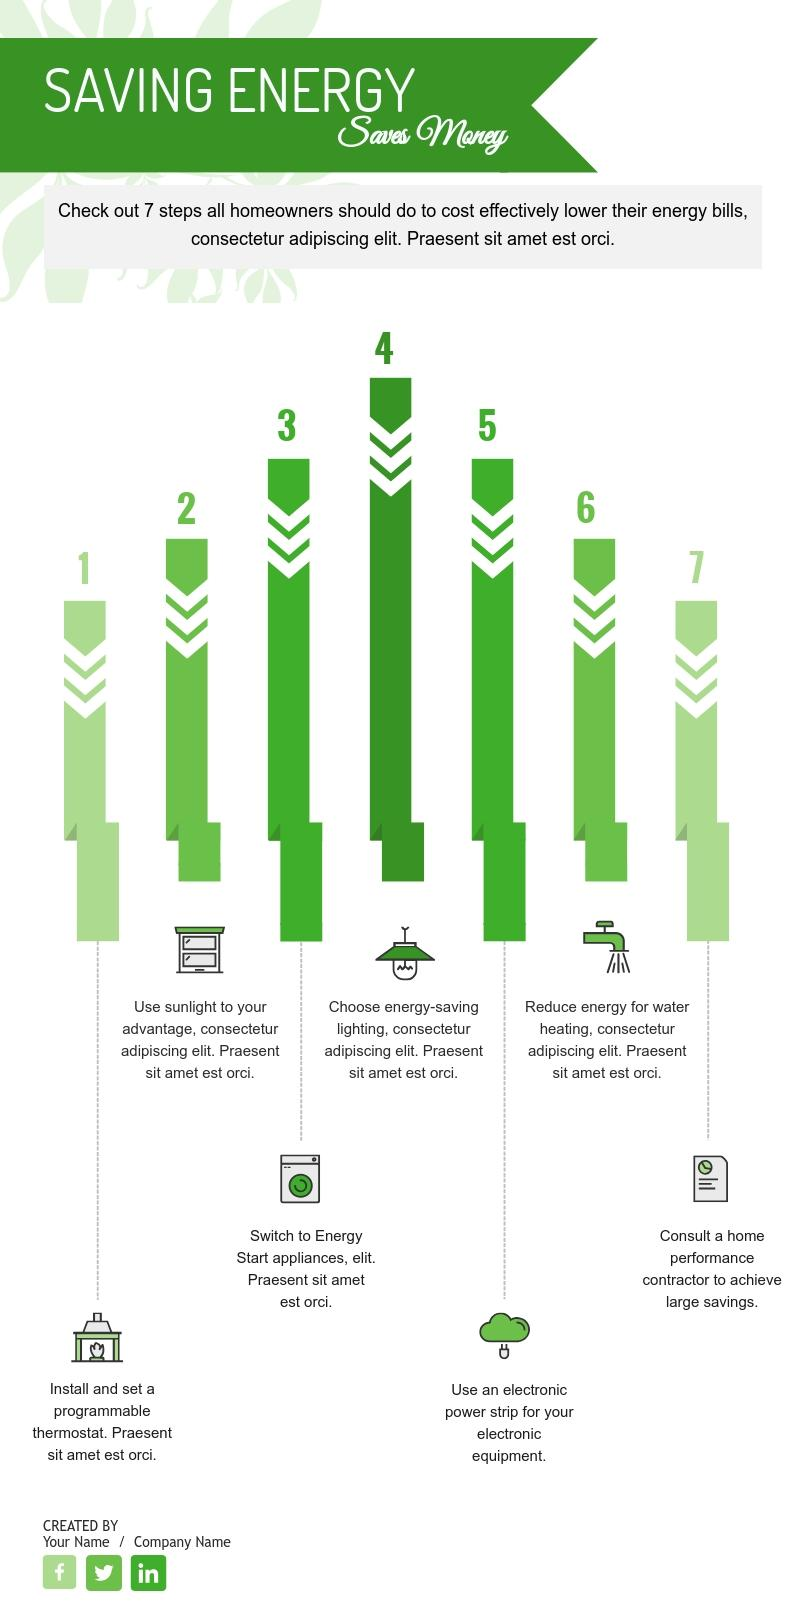Point out several critical features in this image. Using an electronic power strip to turn off power to electronic equipment is the recommended fifth step to lower energy bills. The seventh step recommended to lower energy bills is to consult a home performance contractor to achieve significant savings. 